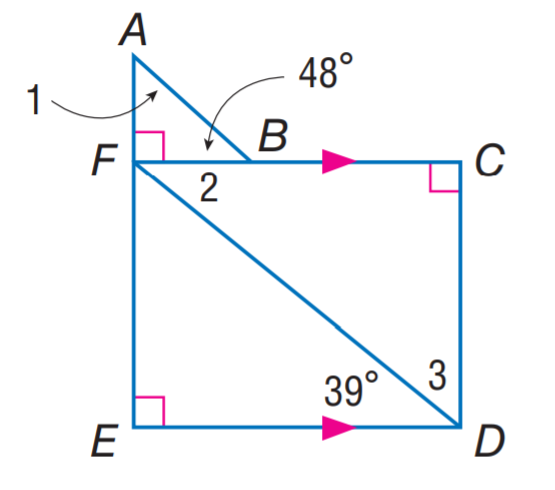Answer the mathemtical geometry problem and directly provide the correct option letter.
Question: Find m \angle 3.
Choices: A: 39 B: 42 C: 48 D: 51 D 